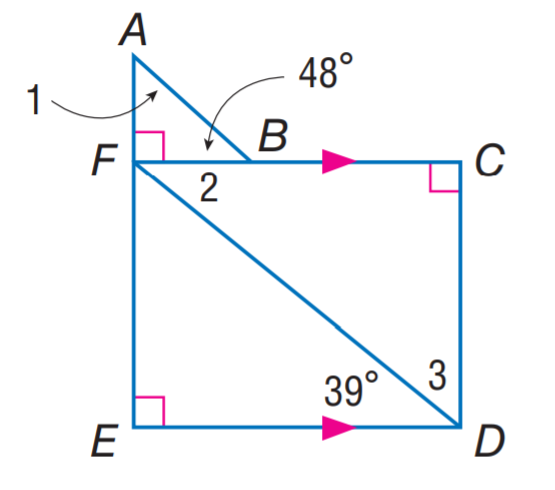Answer the mathemtical geometry problem and directly provide the correct option letter.
Question: Find m \angle 3.
Choices: A: 39 B: 42 C: 48 D: 51 D 